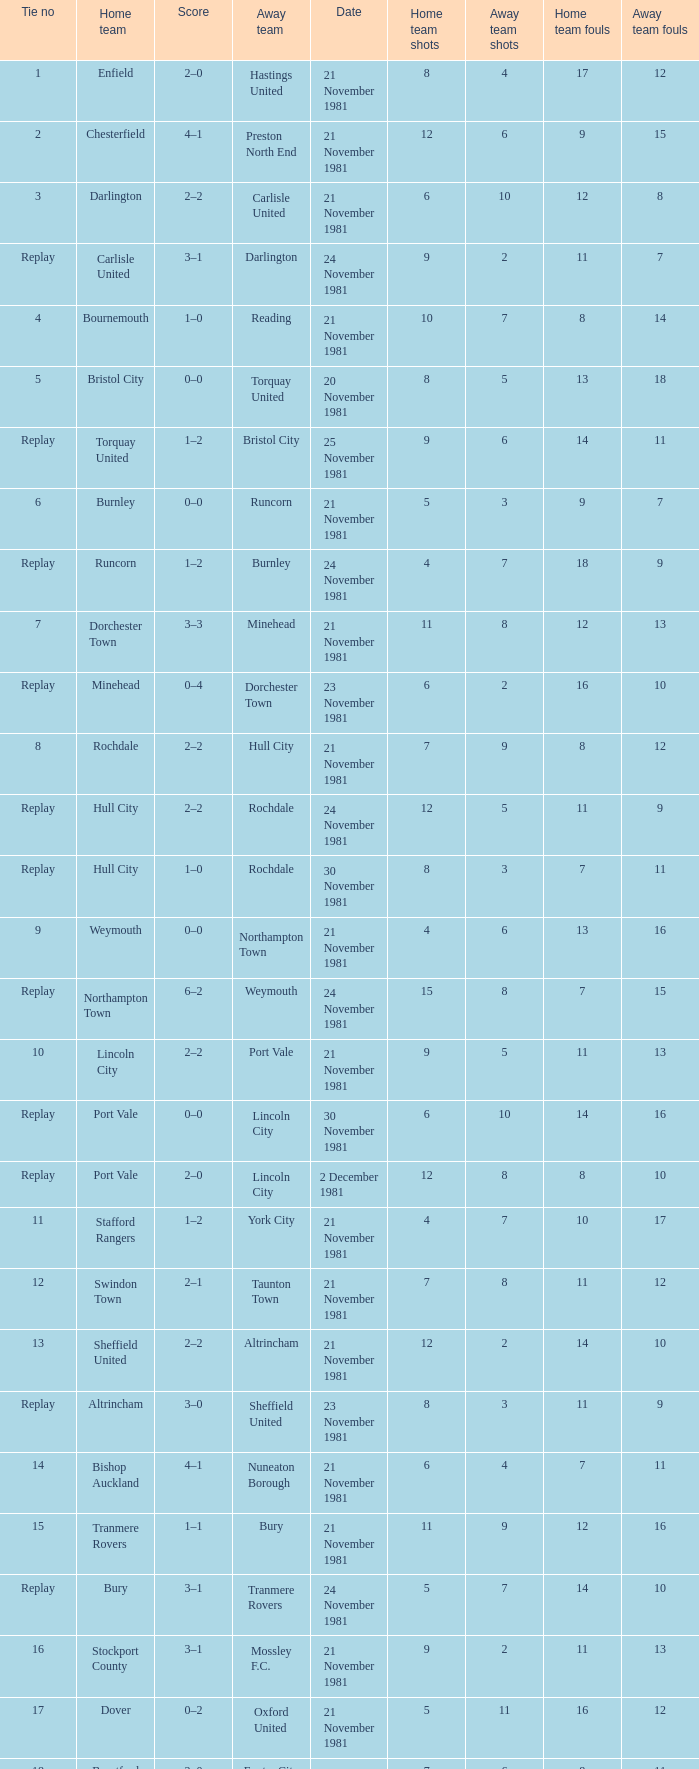Minehead has what tie number? Replay. 